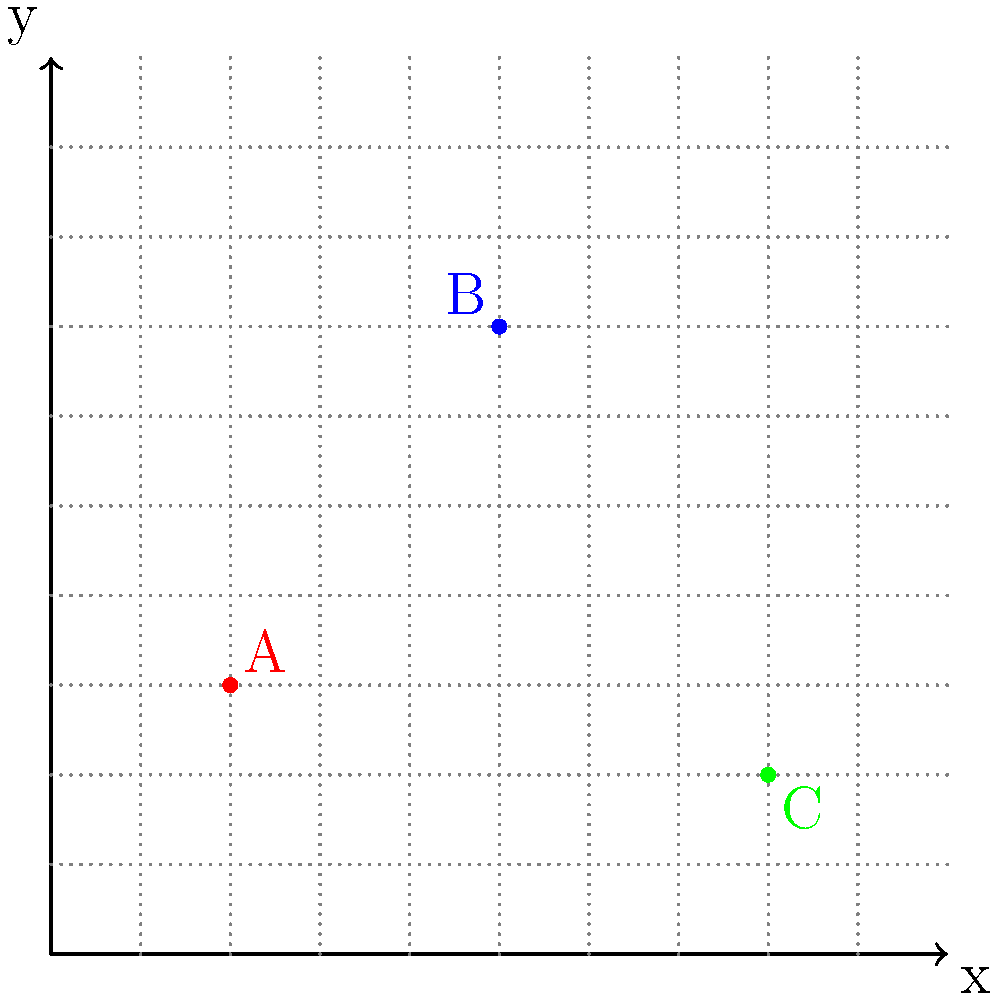As a startup founder, you're analyzing the locations of three main competitors (A, B, and C) in your city. Their positions are plotted on a coordinate grid where each unit represents 1 km. If your office is located at the origin (0,0), what is the Manhattan distance between your office and the competitor that is farthest from you? To solve this problem, we need to follow these steps:

1. Identify the coordinates of each competitor:
   Competitor A: (2, 3)
   Competitor B: (5, 7)
   Competitor C: (8, 2)

2. Calculate the Manhattan distance for each competitor from the origin (0,0). The Manhattan distance is the sum of the absolute differences of the x and y coordinates.

   For A: $|2-0| + |3-0| = 2 + 3 = 5$ km
   For B: $|5-0| + |7-0| = 5 + 7 = 12$ km
   For C: $|8-0| + |2-0| = 8 + 2 = 10$ km

3. Determine the largest distance:
   The largest distance is 12 km, corresponding to competitor B.

Therefore, the competitor farthest from your office (the origin) is B, with a Manhattan distance of 12 km.
Answer: 12 km 